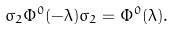<formula> <loc_0><loc_0><loc_500><loc_500>\sigma _ { 2 } \Phi ^ { 0 } ( - \lambda ) \sigma _ { 2 } = \Phi ^ { 0 } ( \lambda ) .</formula> 